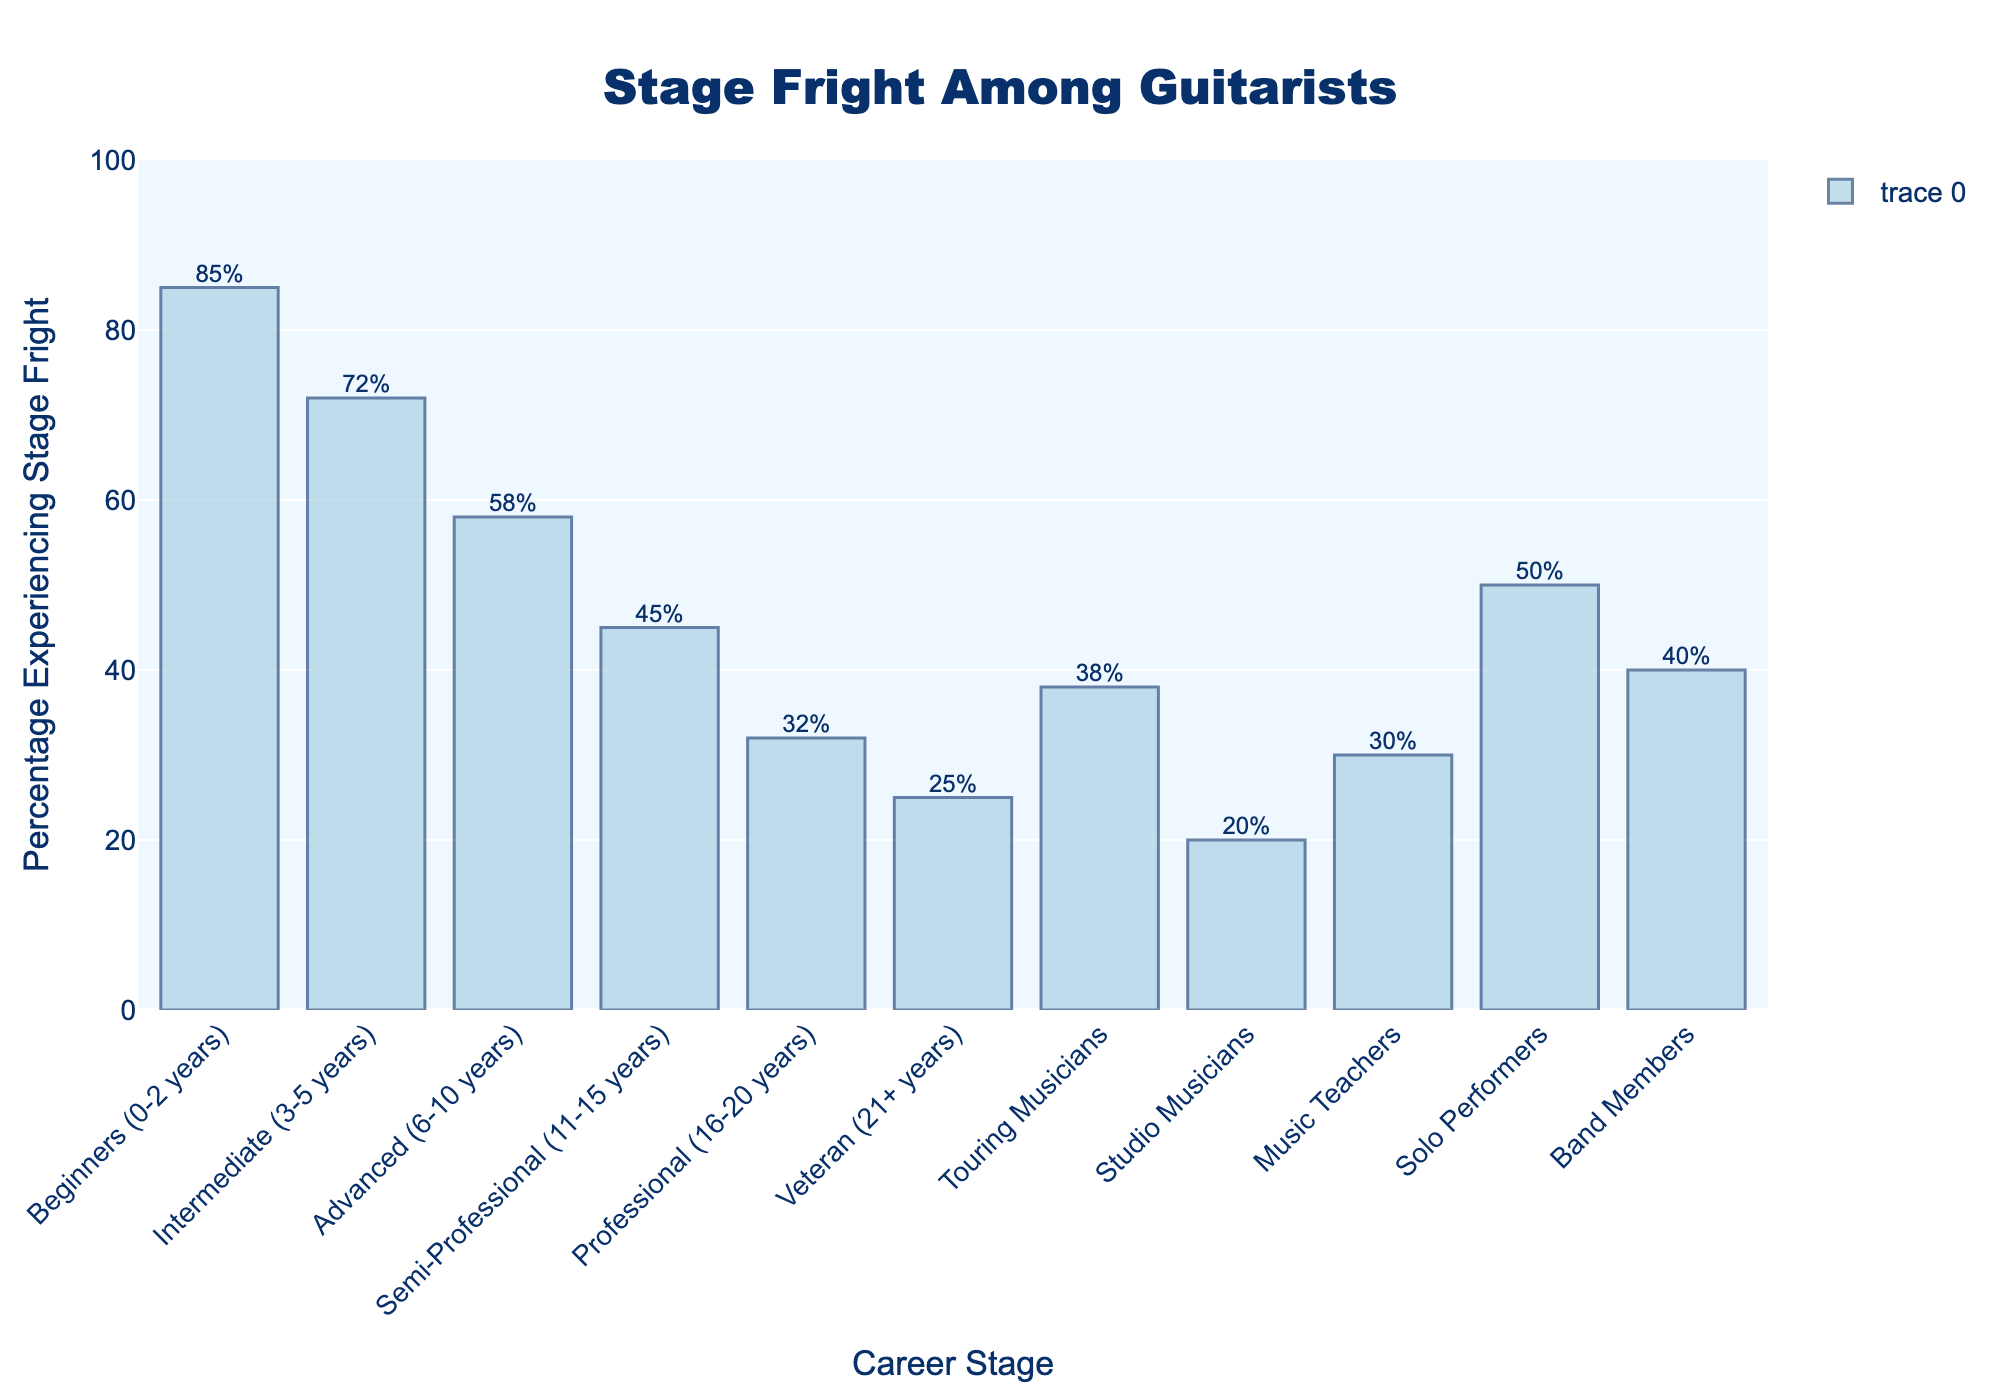Which career stage has the highest percentage of guitarists experiencing stage fright? To find the career stage with the highest percentage of guitarists experiencing stage fright, look for the tallest bar in the chart. The tallest bar corresponds to the "Beginners (0-2 years)" category.
Answer: Beginners (0-2 years) Which career stage has the lowest percentage of guitarists experiencing stage fright? To determine the career stage with the lowest percentage, look for the shortest bar on the chart. The shortest bar corresponds to the "Studio Musicians" category.
Answer: Studio Musicians What's the difference in the percentage of stage fright between Beginners (0-2 years) and Professionals (16-20 years)? First, identify the percentages for Beginners (85%) and Professionals (32%). Subtract the Professional percentage from the Beginner percentage: 85% - 32% = 53%.
Answer: 53% Which career stage has a higher percentage of guitarists experiencing stage fright, Semi-Professional (11-15 years) or Touring Musicians? Compare the heights of the bars for "Semi-Professional (45%)" and "Touring Musicians (38%)". The bar for Semi-Professional is taller, indicating a higher percentage.
Answer: Semi-Professional What is the average percentage of guitarists experiencing stage fright across all listed career stages? Add up all the percentages and divide by the number of career stages listed (11): (85 + 72 + 58 + 45 + 32 + 25 + 38 + 20 + 30 + 50 + 40) / 11 = 495 / 11 ≈ 45%.
Answer: ≈ 45% What is the difference in the percentage of stage fright between Solo Performers and Band Members? Identify the percentages for Solo Performers (50%) and Band Members (40%). Subtract the Band Members percentage from the Solo Performers percentage: 50% - 40% = 10%.
Answer: 10% Are Advanced (6-10 years) guitarists experiencing more or less stage fright compared to Veterans (21+ years)? Compare the heights of the bars for Advanced (58%) and Veterans (25%). The bar for Advanced is taller, indicating they experience more stage fright.
Answer: More What's the combined percentage of guitarists experiencing stage fright in the Intermediate (3-5 years) and Semi-Professional (11-15 years) stages? Add the percentages for Intermediate (72%) and Semi-Professional (45%): 72% + 45% = 117%.
Answer: 117% Among professional categories (Professional, Veteran, Touring Musicians, Studio Musicians, Music Teachers), which one has the second lowest percentage of stage fright? Identify the percentages: Professional (32%), Veteran (25%), Touring Musicians (38%), Studio Musicians (20%), Music Teachers (30%). The second lowest percentage is for Music Teachers (30%).
Answer: Music Teachers By how much does the percentage of stage fright decrease from Beginners (0-2 years) to Advanced (6-10 years)? First, identify the percentages for Beginners (85%) and Advanced (58%). Subtract the Advanced percentage from the Beginner percentage: 85% - 58% = 27%.
Answer: 27% 